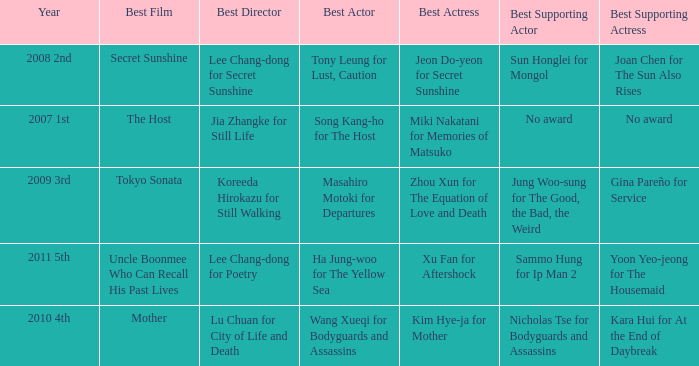Name the year for sammo hung for ip man 2 2011 5th. 